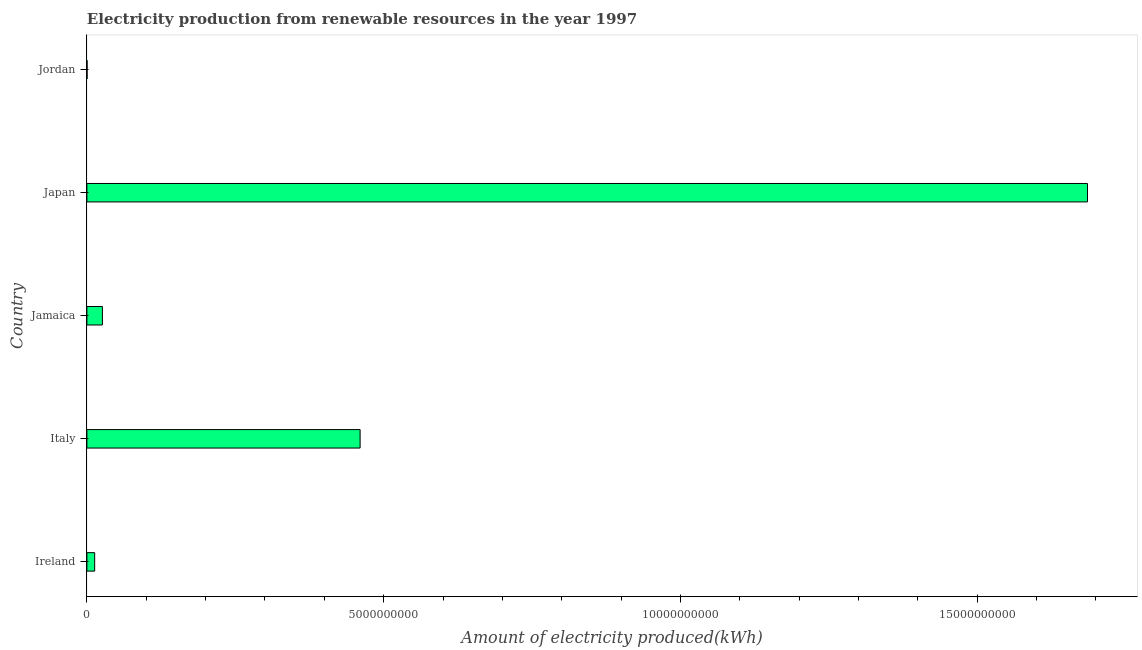Does the graph contain any zero values?
Provide a short and direct response. No. Does the graph contain grids?
Give a very brief answer. No. What is the title of the graph?
Provide a short and direct response. Electricity production from renewable resources in the year 1997. What is the label or title of the X-axis?
Ensure brevity in your answer.  Amount of electricity produced(kWh). What is the label or title of the Y-axis?
Provide a succinct answer. Country. What is the amount of electricity produced in Jamaica?
Keep it short and to the point. 2.61e+08. Across all countries, what is the maximum amount of electricity produced?
Offer a very short reply. 1.69e+1. In which country was the amount of electricity produced minimum?
Your response must be concise. Jordan. What is the sum of the amount of electricity produced?
Your response must be concise. 2.19e+1. What is the difference between the amount of electricity produced in Jamaica and Japan?
Your answer should be compact. -1.66e+1. What is the average amount of electricity produced per country?
Offer a very short reply. 4.37e+09. What is the median amount of electricity produced?
Your answer should be compact. 2.61e+08. In how many countries, is the amount of electricity produced greater than 13000000000 kWh?
Your response must be concise. 1. What is the ratio of the amount of electricity produced in Italy to that in Japan?
Offer a very short reply. 0.27. Is the difference between the amount of electricity produced in Italy and Jordan greater than the difference between any two countries?
Your response must be concise. No. What is the difference between the highest and the second highest amount of electricity produced?
Offer a terse response. 1.23e+1. Is the sum of the amount of electricity produced in Ireland and Jordan greater than the maximum amount of electricity produced across all countries?
Provide a succinct answer. No. What is the difference between the highest and the lowest amount of electricity produced?
Your response must be concise. 1.69e+1. How many bars are there?
Provide a short and direct response. 5. What is the difference between two consecutive major ticks on the X-axis?
Make the answer very short. 5.00e+09. Are the values on the major ticks of X-axis written in scientific E-notation?
Keep it short and to the point. No. What is the Amount of electricity produced(kWh) in Ireland?
Ensure brevity in your answer.  1.31e+08. What is the Amount of electricity produced(kWh) of Italy?
Make the answer very short. 4.60e+09. What is the Amount of electricity produced(kWh) in Jamaica?
Your answer should be compact. 2.61e+08. What is the Amount of electricity produced(kWh) of Japan?
Ensure brevity in your answer.  1.69e+1. What is the Amount of electricity produced(kWh) in Jordan?
Provide a short and direct response. 3.00e+06. What is the difference between the Amount of electricity produced(kWh) in Ireland and Italy?
Keep it short and to the point. -4.47e+09. What is the difference between the Amount of electricity produced(kWh) in Ireland and Jamaica?
Keep it short and to the point. -1.30e+08. What is the difference between the Amount of electricity produced(kWh) in Ireland and Japan?
Your answer should be very brief. -1.67e+1. What is the difference between the Amount of electricity produced(kWh) in Ireland and Jordan?
Give a very brief answer. 1.28e+08. What is the difference between the Amount of electricity produced(kWh) in Italy and Jamaica?
Offer a terse response. 4.34e+09. What is the difference between the Amount of electricity produced(kWh) in Italy and Japan?
Offer a terse response. -1.23e+1. What is the difference between the Amount of electricity produced(kWh) in Italy and Jordan?
Provide a short and direct response. 4.60e+09. What is the difference between the Amount of electricity produced(kWh) in Jamaica and Japan?
Provide a short and direct response. -1.66e+1. What is the difference between the Amount of electricity produced(kWh) in Jamaica and Jordan?
Provide a succinct answer. 2.58e+08. What is the difference between the Amount of electricity produced(kWh) in Japan and Jordan?
Make the answer very short. 1.69e+1. What is the ratio of the Amount of electricity produced(kWh) in Ireland to that in Italy?
Ensure brevity in your answer.  0.03. What is the ratio of the Amount of electricity produced(kWh) in Ireland to that in Jamaica?
Your answer should be very brief. 0.5. What is the ratio of the Amount of electricity produced(kWh) in Ireland to that in Japan?
Offer a terse response. 0.01. What is the ratio of the Amount of electricity produced(kWh) in Ireland to that in Jordan?
Make the answer very short. 43.67. What is the ratio of the Amount of electricity produced(kWh) in Italy to that in Jamaica?
Provide a succinct answer. 17.64. What is the ratio of the Amount of electricity produced(kWh) in Italy to that in Japan?
Offer a terse response. 0.27. What is the ratio of the Amount of electricity produced(kWh) in Italy to that in Jordan?
Provide a succinct answer. 1534.33. What is the ratio of the Amount of electricity produced(kWh) in Jamaica to that in Japan?
Provide a short and direct response. 0.01. What is the ratio of the Amount of electricity produced(kWh) in Jamaica to that in Jordan?
Your response must be concise. 87. What is the ratio of the Amount of electricity produced(kWh) in Japan to that in Jordan?
Your answer should be compact. 5619. 